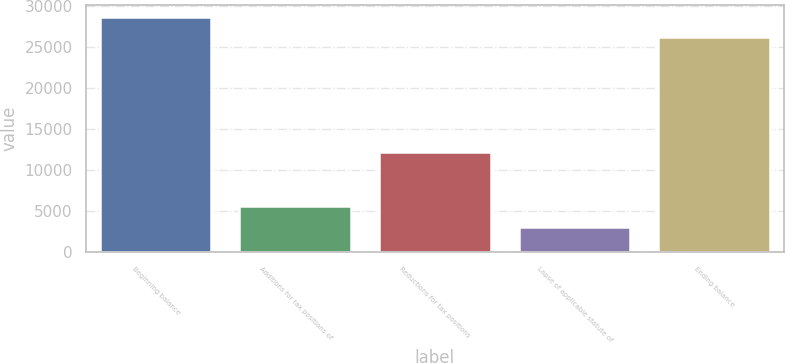Convert chart. <chart><loc_0><loc_0><loc_500><loc_500><bar_chart><fcel>Beginning balance<fcel>Additions for tax positions of<fcel>Reductions for tax positions<fcel>Lapse of applicable statute of<fcel>Ending balance<nl><fcel>28688.7<fcel>5628.7<fcel>12206<fcel>3080<fcel>26140<nl></chart> 